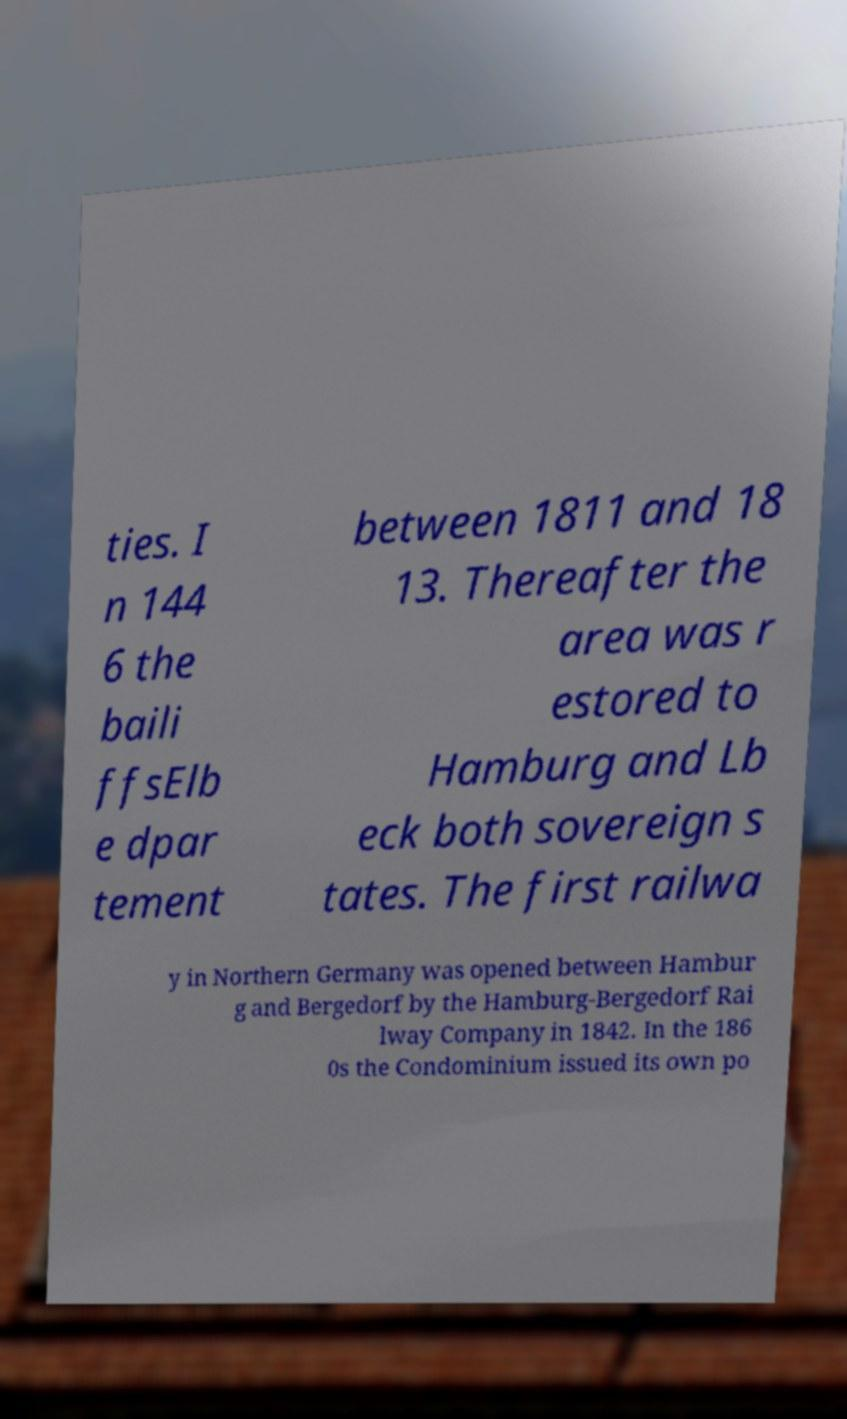Can you read and provide the text displayed in the image?This photo seems to have some interesting text. Can you extract and type it out for me? ties. I n 144 6 the baili ffsElb e dpar tement between 1811 and 18 13. Thereafter the area was r estored to Hamburg and Lb eck both sovereign s tates. The first railwa y in Northern Germany was opened between Hambur g and Bergedorf by the Hamburg-Bergedorf Rai lway Company in 1842. In the 186 0s the Condominium issued its own po 